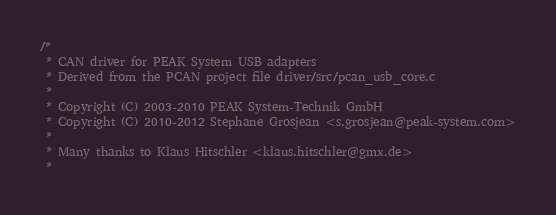<code> <loc_0><loc_0><loc_500><loc_500><_C_>/*
 * CAN driver for PEAK System USB adapters
 * Derived from the PCAN project file driver/src/pcan_usb_core.c
 *
 * Copyright (C) 2003-2010 PEAK System-Technik GmbH
 * Copyright (C) 2010-2012 Stephane Grosjean <s.grosjean@peak-system.com>
 *
 * Many thanks to Klaus Hitschler <klaus.hitschler@gmx.de>
 *</code> 